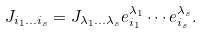Convert formula to latex. <formula><loc_0><loc_0><loc_500><loc_500>J _ { i _ { 1 } \dots i _ { s } } = J _ { \lambda _ { 1 } \dots \lambda _ { s } } e ^ { \lambda _ { 1 } } _ { i _ { 1 } } \cdots e ^ { \lambda _ { s } } _ { i _ { s } } .</formula> 